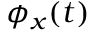<formula> <loc_0><loc_0><loc_500><loc_500>\phi _ { x } ( t )</formula> 